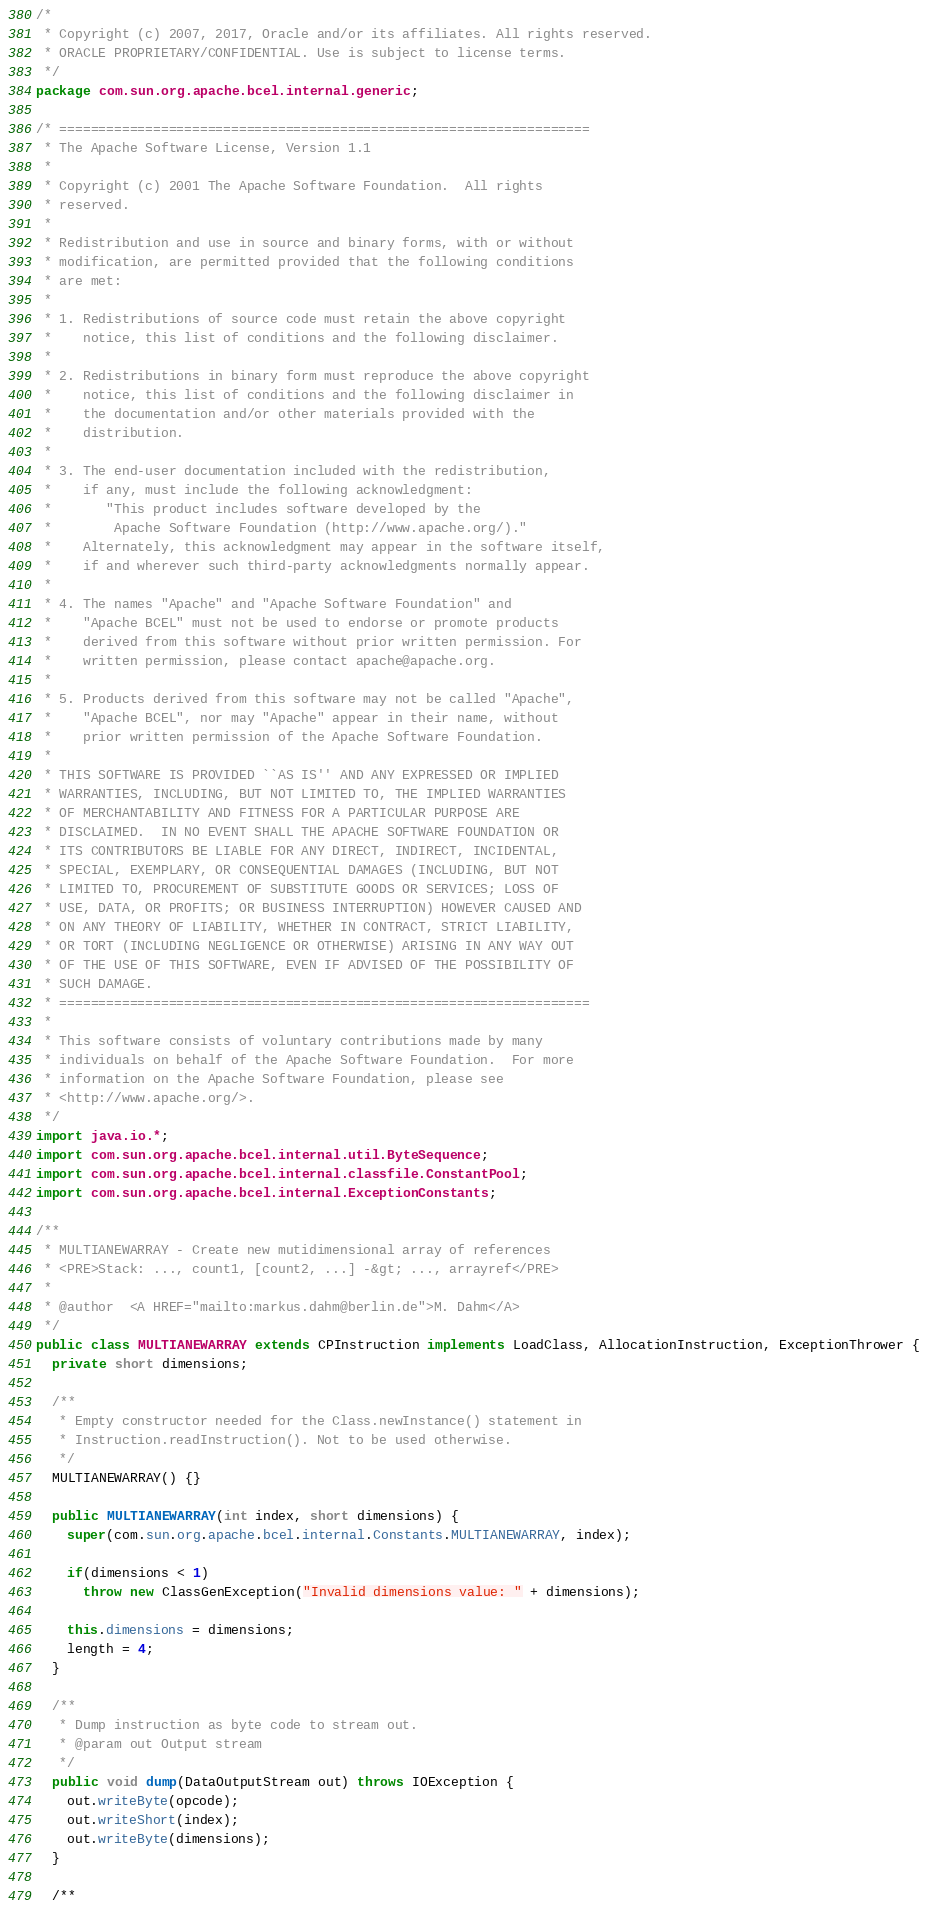<code> <loc_0><loc_0><loc_500><loc_500><_Java_>/*
 * Copyright (c) 2007, 2017, Oracle and/or its affiliates. All rights reserved.
 * ORACLE PROPRIETARY/CONFIDENTIAL. Use is subject to license terms.
 */
package com.sun.org.apache.bcel.internal.generic;

/* ====================================================================
 * The Apache Software License, Version 1.1
 *
 * Copyright (c) 2001 The Apache Software Foundation.  All rights
 * reserved.
 *
 * Redistribution and use in source and binary forms, with or without
 * modification, are permitted provided that the following conditions
 * are met:
 *
 * 1. Redistributions of source code must retain the above copyright
 *    notice, this list of conditions and the following disclaimer.
 *
 * 2. Redistributions in binary form must reproduce the above copyright
 *    notice, this list of conditions and the following disclaimer in
 *    the documentation and/or other materials provided with the
 *    distribution.
 *
 * 3. The end-user documentation included with the redistribution,
 *    if any, must include the following acknowledgment:
 *       "This product includes software developed by the
 *        Apache Software Foundation (http://www.apache.org/)."
 *    Alternately, this acknowledgment may appear in the software itself,
 *    if and wherever such third-party acknowledgments normally appear.
 *
 * 4. The names "Apache" and "Apache Software Foundation" and
 *    "Apache BCEL" must not be used to endorse or promote products
 *    derived from this software without prior written permission. For
 *    written permission, please contact apache@apache.org.
 *
 * 5. Products derived from this software may not be called "Apache",
 *    "Apache BCEL", nor may "Apache" appear in their name, without
 *    prior written permission of the Apache Software Foundation.
 *
 * THIS SOFTWARE IS PROVIDED ``AS IS'' AND ANY EXPRESSED OR IMPLIED
 * WARRANTIES, INCLUDING, BUT NOT LIMITED TO, THE IMPLIED WARRANTIES
 * OF MERCHANTABILITY AND FITNESS FOR A PARTICULAR PURPOSE ARE
 * DISCLAIMED.  IN NO EVENT SHALL THE APACHE SOFTWARE FOUNDATION OR
 * ITS CONTRIBUTORS BE LIABLE FOR ANY DIRECT, INDIRECT, INCIDENTAL,
 * SPECIAL, EXEMPLARY, OR CONSEQUENTIAL DAMAGES (INCLUDING, BUT NOT
 * LIMITED TO, PROCUREMENT OF SUBSTITUTE GOODS OR SERVICES; LOSS OF
 * USE, DATA, OR PROFITS; OR BUSINESS INTERRUPTION) HOWEVER CAUSED AND
 * ON ANY THEORY OF LIABILITY, WHETHER IN CONTRACT, STRICT LIABILITY,
 * OR TORT (INCLUDING NEGLIGENCE OR OTHERWISE) ARISING IN ANY WAY OUT
 * OF THE USE OF THIS SOFTWARE, EVEN IF ADVISED OF THE POSSIBILITY OF
 * SUCH DAMAGE.
 * ====================================================================
 *
 * This software consists of voluntary contributions made by many
 * individuals on behalf of the Apache Software Foundation.  For more
 * information on the Apache Software Foundation, please see
 * <http://www.apache.org/>.
 */
import java.io.*;
import com.sun.org.apache.bcel.internal.util.ByteSequence;
import com.sun.org.apache.bcel.internal.classfile.ConstantPool;
import com.sun.org.apache.bcel.internal.ExceptionConstants;

/**
 * MULTIANEWARRAY - Create new mutidimensional array of references
 * <PRE>Stack: ..., count1, [count2, ...] -&gt; ..., arrayref</PRE>
 *
 * @author  <A HREF="mailto:markus.dahm@berlin.de">M. Dahm</A>
 */
public class MULTIANEWARRAY extends CPInstruction implements LoadClass, AllocationInstruction, ExceptionThrower {
  private short dimensions;

  /**
   * Empty constructor needed for the Class.newInstance() statement in
   * Instruction.readInstruction(). Not to be used otherwise.
   */
  MULTIANEWARRAY() {}

  public MULTIANEWARRAY(int index, short dimensions) {
    super(com.sun.org.apache.bcel.internal.Constants.MULTIANEWARRAY, index);

    if(dimensions < 1)
      throw new ClassGenException("Invalid dimensions value: " + dimensions);

    this.dimensions = dimensions;
    length = 4;
  }

  /**
   * Dump instruction as byte code to stream out.
   * @param out Output stream
   */
  public void dump(DataOutputStream out) throws IOException {
    out.writeByte(opcode);
    out.writeShort(index);
    out.writeByte(dimensions);
  }

  /**</code> 